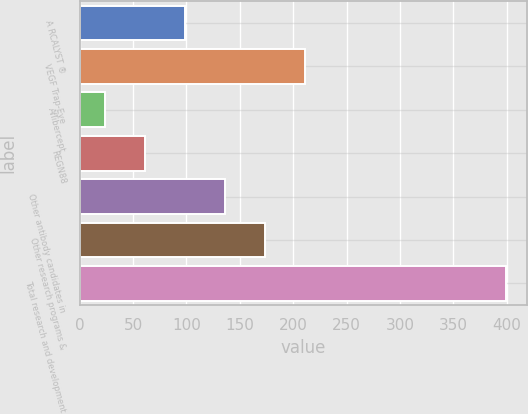Convert chart to OTSL. <chart><loc_0><loc_0><loc_500><loc_500><bar_chart><fcel>A RCALYST ®<fcel>VEGF Trap-Eye<fcel>Aflibercept<fcel>REGN88<fcel>Other antibody candidates in<fcel>Other research programs &<fcel>Total research and development<nl><fcel>98.4<fcel>211.05<fcel>23.3<fcel>60.85<fcel>135.95<fcel>173.5<fcel>398.8<nl></chart> 